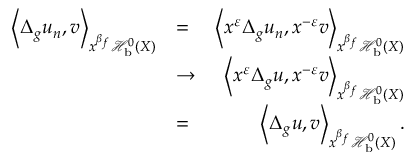Convert formula to latex. <formula><loc_0><loc_0><loc_500><loc_500>\begin{array} { r l r } { \left < \Delta _ { g } u _ { n } , v \right > _ { x ^ { \beta _ { f } } \mathcal { H } _ { b } ^ { 0 } ( X ) } } & { = } & { \left < x ^ { \varepsilon } \Delta _ { g } u _ { n } , x ^ { - \varepsilon } v \right > _ { x ^ { \beta _ { f } } \mathcal { H } _ { b } ^ { 0 } ( X ) } } \\ & { \to } & { \left < x ^ { \varepsilon } \Delta _ { g } u , x ^ { - \varepsilon } v \right > _ { x ^ { \beta _ { f } } \mathcal { H } _ { b } ^ { 0 } ( X ) } } \\ & { = } & { \left < \Delta _ { g } u , v \right > _ { x ^ { \beta _ { f } } \mathcal { H } _ { b } ^ { 0 } ( X ) } . } \end{array}</formula> 